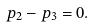<formula> <loc_0><loc_0><loc_500><loc_500>p _ { 2 } - p _ { 3 } = 0 .</formula> 